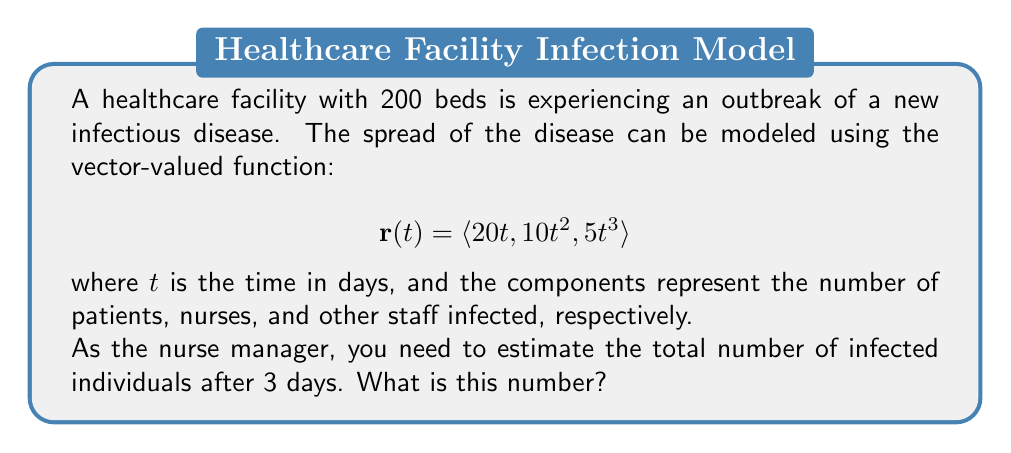Provide a solution to this math problem. To solve this problem, we need to follow these steps:

1) The vector-valued function gives us the number of infected individuals in each category at time $t$:
   - Patients: $20t$
   - Nurses: $10t^2$
   - Other staff: $5t^3$

2) We need to evaluate this function at $t = 3$ days:

   $$\mathbf{r}(3) = \langle 20(3), 10(3)^2, 5(3)^3 \rangle$$

3) Let's calculate each component:
   - Patients: $20(3) = 60$
   - Nurses: $10(3)^2 = 10(9) = 90$
   - Other staff: $5(3)^3 = 5(27) = 135$

4) Now we have the vector:

   $$\mathbf{r}(3) = \langle 60, 90, 135 \rangle$$

5) To get the total number of infected individuals, we sum these components:

   $60 + 90 + 135 = 285$

Therefore, after 3 days, the estimated total number of infected individuals is 285.
Answer: 285 